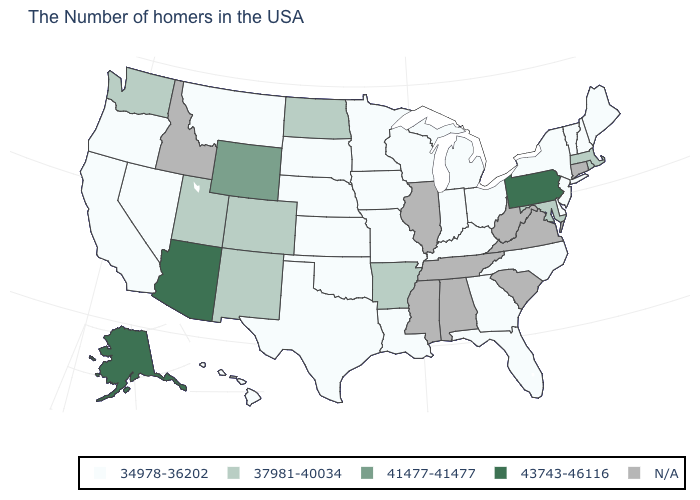What is the value of Maine?
Be succinct. 34978-36202. What is the lowest value in the USA?
Concise answer only. 34978-36202. What is the value of South Carolina?
Write a very short answer. N/A. What is the highest value in the Northeast ?
Be succinct. 43743-46116. Among the states that border New Mexico , which have the lowest value?
Be succinct. Oklahoma, Texas. What is the value of North Carolina?
Keep it brief. 34978-36202. What is the value of Massachusetts?
Be succinct. 37981-40034. What is the value of Georgia?
Write a very short answer. 34978-36202. What is the value of Colorado?
Concise answer only. 37981-40034. What is the lowest value in states that border Rhode Island?
Answer briefly. 37981-40034. Name the states that have a value in the range N/A?
Keep it brief. Connecticut, Virginia, South Carolina, West Virginia, Alabama, Tennessee, Illinois, Mississippi, Idaho. Is the legend a continuous bar?
Concise answer only. No. What is the value of New Jersey?
Keep it brief. 34978-36202. What is the value of California?
Concise answer only. 34978-36202. 